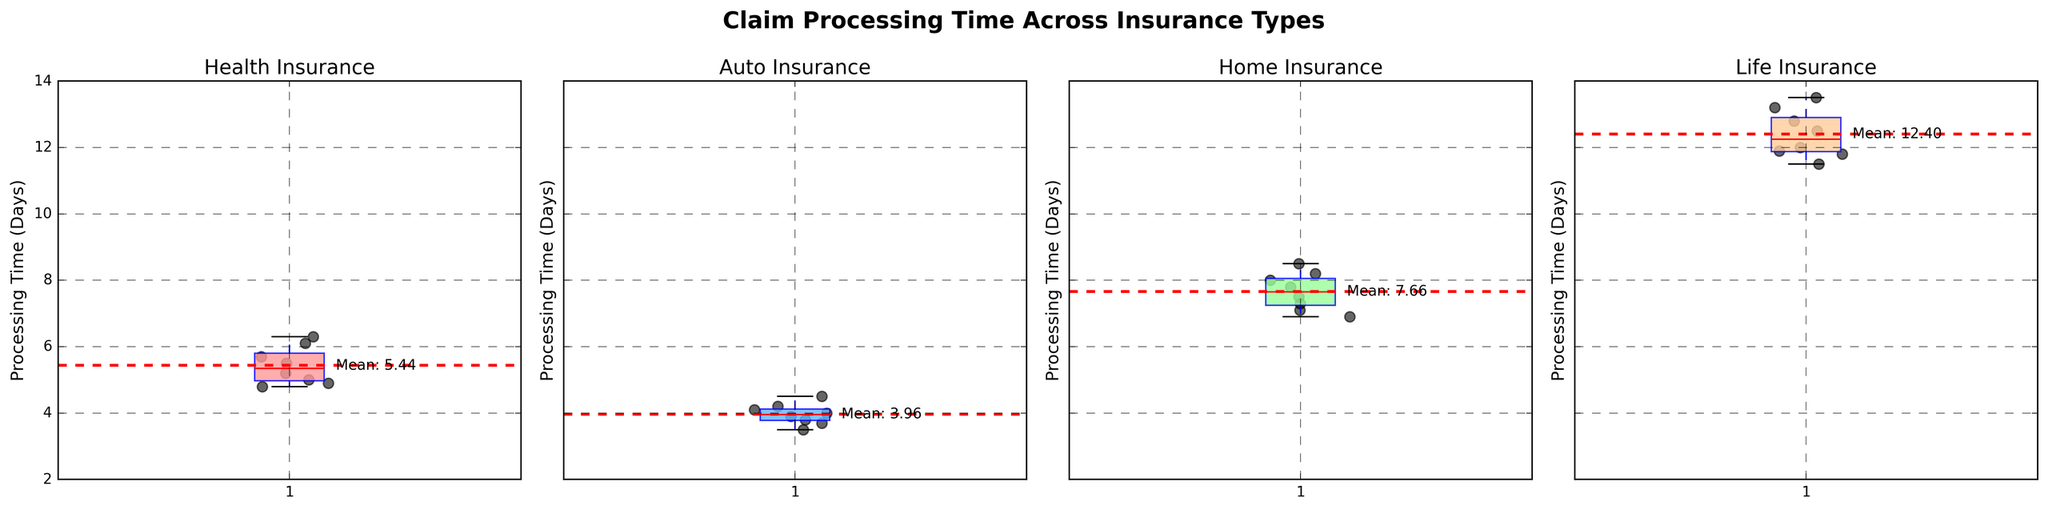What is the average claim processing time for Health insurance? The plot for Health insurance shows the mean processing time with a red dashed line marked "Mean: 5.56". Therefore, the average claim processing time is approximately 5.56 days.
Answer: 5.56 Among the four insurance types, which one has the longest average claim processing time? By observing the plots, we see red dashed lines (mean) for each insurance type. The mean line is highest for Life insurance, marked "Mean: 12.4". Thus, Life insurance has the longest average claim processing time.
Answer: Life Compare the median claim processing times between Auto and Home insurance. Which is higher? To compare the medians, we look at the central horizontal line within each box plot. The median line for Auto insurance is lower than the median line for Home insurance. Therefore, the median claim processing time is higher for Home insurance.
Answer: Home Are the claim processing times for Auto insurance more tightly clustered than those for Life insurance? To determine clustering, we look at the width of the boxplots. The box for Auto insurance is narrower than that for Life insurance. Thus, Auto insurance claim processing times are more tightly clustered.
Answer: Yes What is the approximate range of claim processing times for Home insurance? The range is observed by noting the bottom and top whiskers of the Home insurance boxplot. The minimum is around 6.9 days, and the maximum is around 8.5 days, making the range approximately 1.6 days.
Answer: 1.6 days Which insurance type has the lowest variability in claim processing times? Variability can be judged by the interquartile range (IQR). The narrowest boxplot indicates the lowest IQR. Auto insurance has the narrower boxplot among all the insurance types, indicating it has the lowest variability.
Answer: Auto How does the mean processing time for Health insurance compare to the median processing time for Life insurance? The mean processing time for Health insurance is around 5.56 days, while the median line for Life insurance is visibly around 12.0 days. Thus, the mean processing time for Health insurance is lower.
Answer: Lower Does any insurance type have an outlier in claim processing times? Outliers are typically represented as individual points beyond the whiskers of boxplots. Reviewing all subplots, no single dot falls far outside the whiskers, indicating no visible outliers for any insurance type.
Answer: No Among the listed insurance types, which one shows the highest consistency in the processing times around the mean value? Consistency around the mean can be observed by the density of points near the red dashed line. Auto insurance shows points densely clustered near its mean line, indicating high consistency.
Answer: Auto Which insurance types have mean processing times between 6 and 10 days? By looking at the red dashed mean lines in each subplot, Health and Home insurance have mean lines falling within the 6 to 10 days range. Health’s mean is around 5.56 (close to the lower bound), and Home’s mean is around 7.78.
Answer: Health and Home 